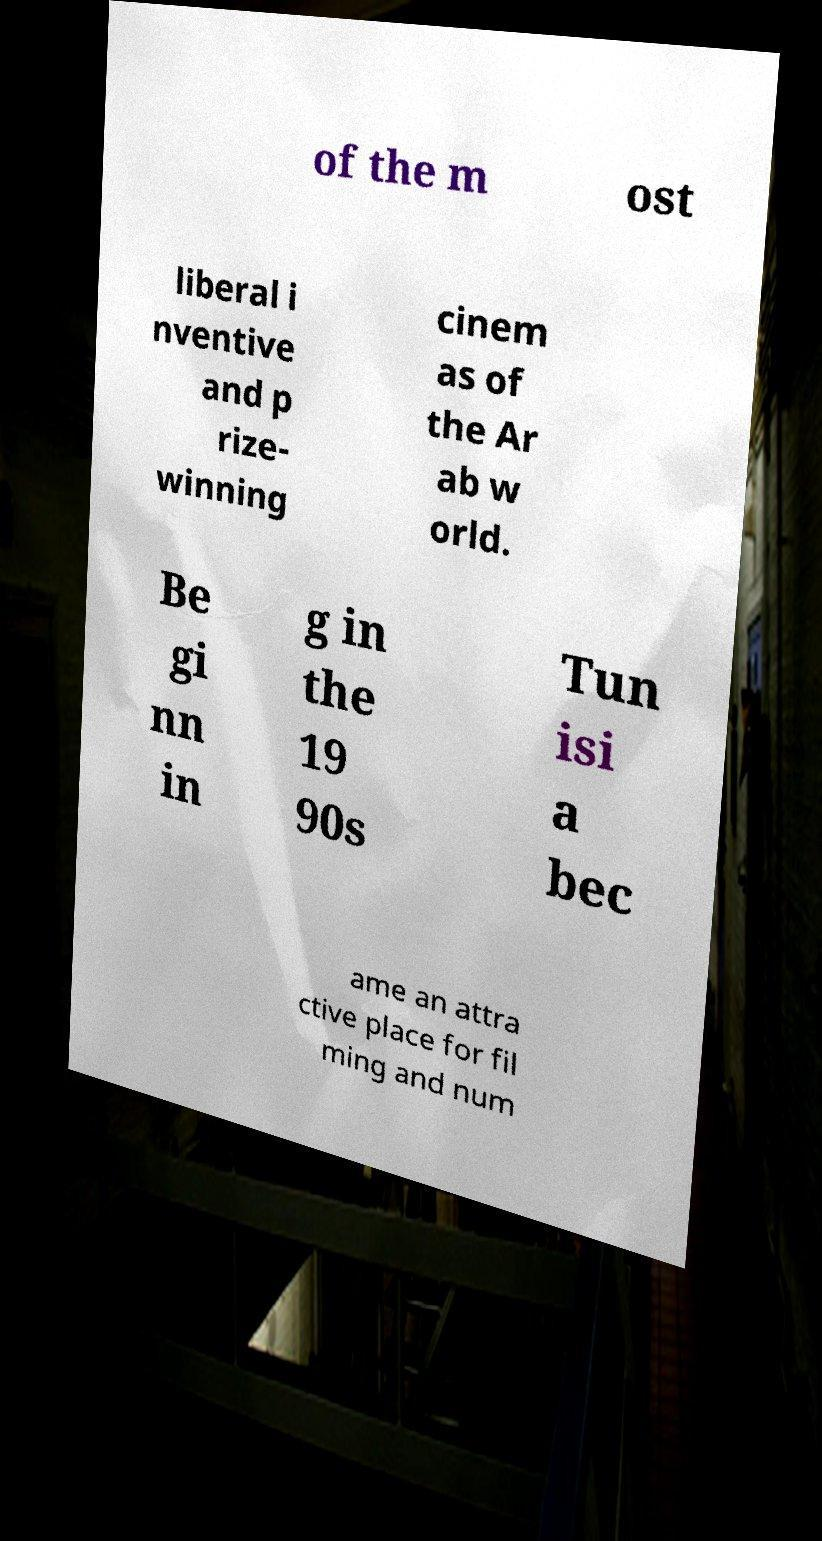There's text embedded in this image that I need extracted. Can you transcribe it verbatim? of the m ost liberal i nventive and p rize- winning cinem as of the Ar ab w orld. Be gi nn in g in the 19 90s Tun isi a bec ame an attra ctive place for fil ming and num 